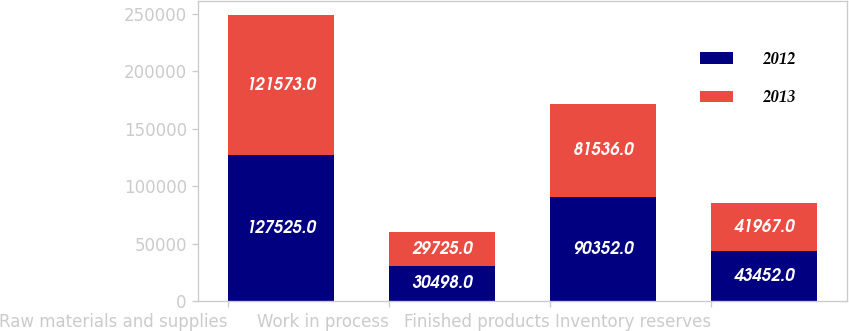<chart> <loc_0><loc_0><loc_500><loc_500><stacked_bar_chart><ecel><fcel>Raw materials and supplies<fcel>Work in process<fcel>Finished products<fcel>Inventory reserves<nl><fcel>2012<fcel>127525<fcel>30498<fcel>90352<fcel>43452<nl><fcel>2013<fcel>121573<fcel>29725<fcel>81536<fcel>41967<nl></chart> 